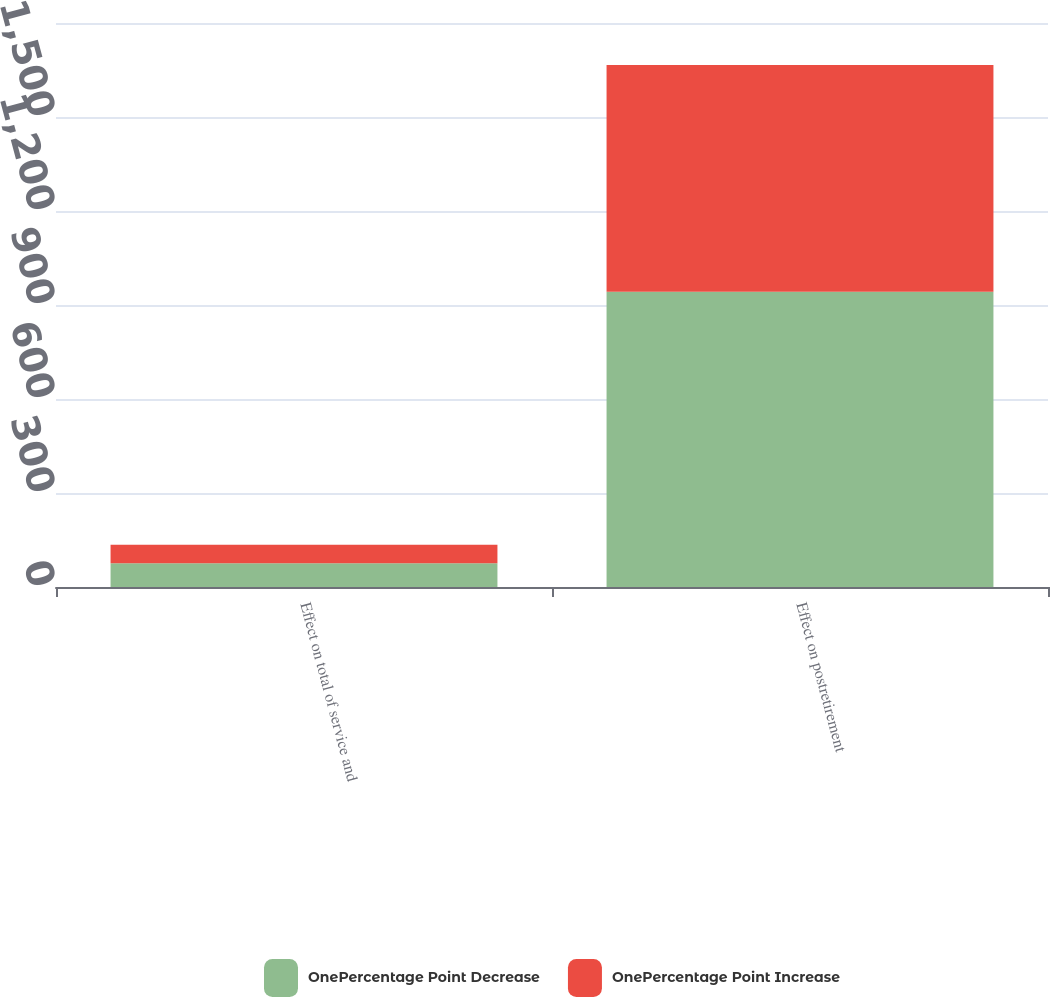<chart> <loc_0><loc_0><loc_500><loc_500><stacked_bar_chart><ecel><fcel>Effect on total of service and<fcel>Effect on postretirement<nl><fcel>OnePercentage Point Decrease<fcel>76<fcel>942<nl><fcel>OnePercentage Point Increase<fcel>59<fcel>724<nl></chart> 